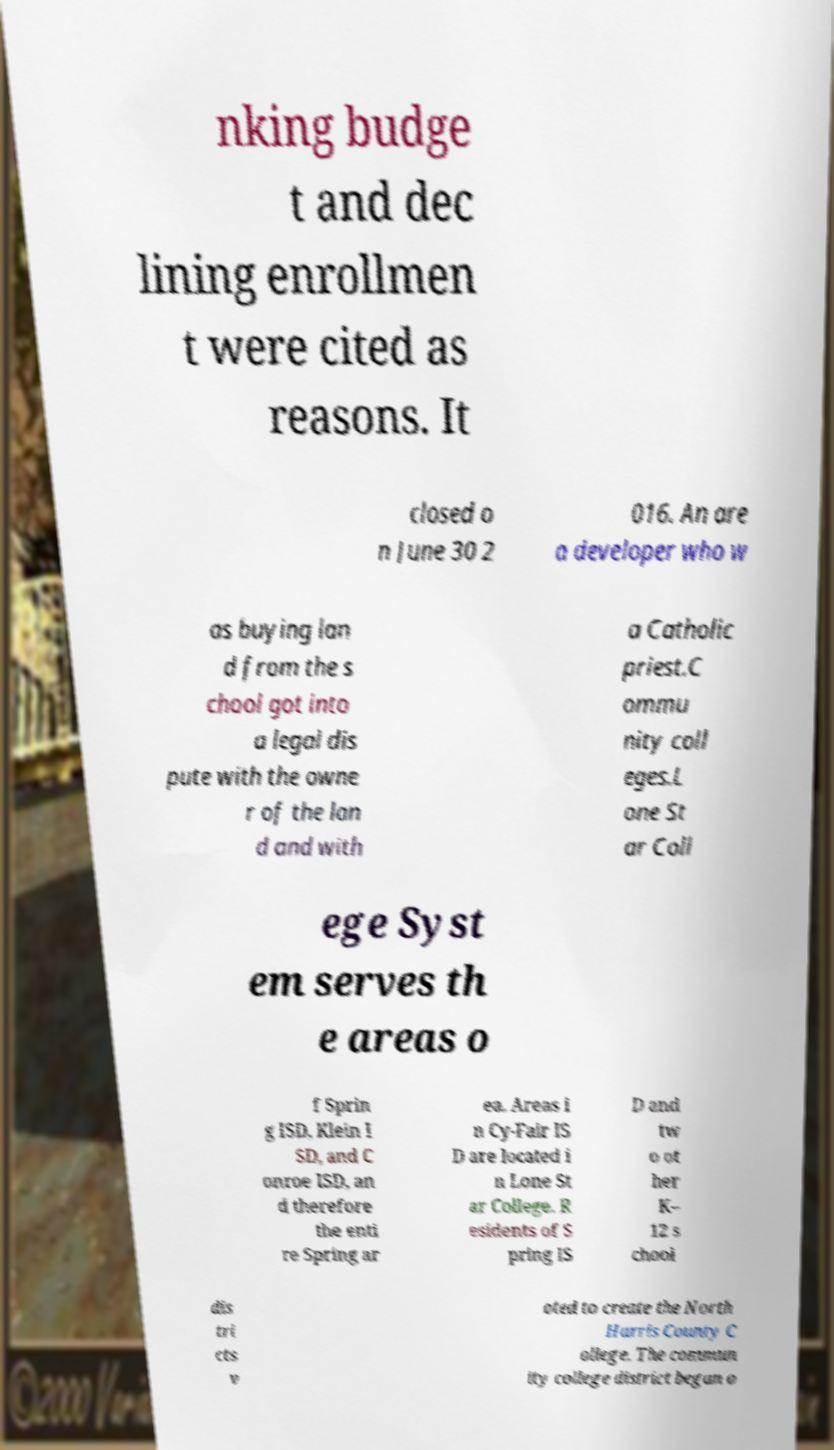I need the written content from this picture converted into text. Can you do that? nking budge t and dec lining enrollmen t were cited as reasons. It closed o n June 30 2 016. An are a developer who w as buying lan d from the s chool got into a legal dis pute with the owne r of the lan d and with a Catholic priest.C ommu nity coll eges.L one St ar Coll ege Syst em serves th e areas o f Sprin g ISD, Klein I SD, and C onroe ISD, an d therefore the enti re Spring ar ea. Areas i n Cy-Fair IS D are located i n Lone St ar College. R esidents of S pring IS D and tw o ot her K– 12 s chool dis tri cts v oted to create the North Harris County C ollege. The commun ity college district began o 